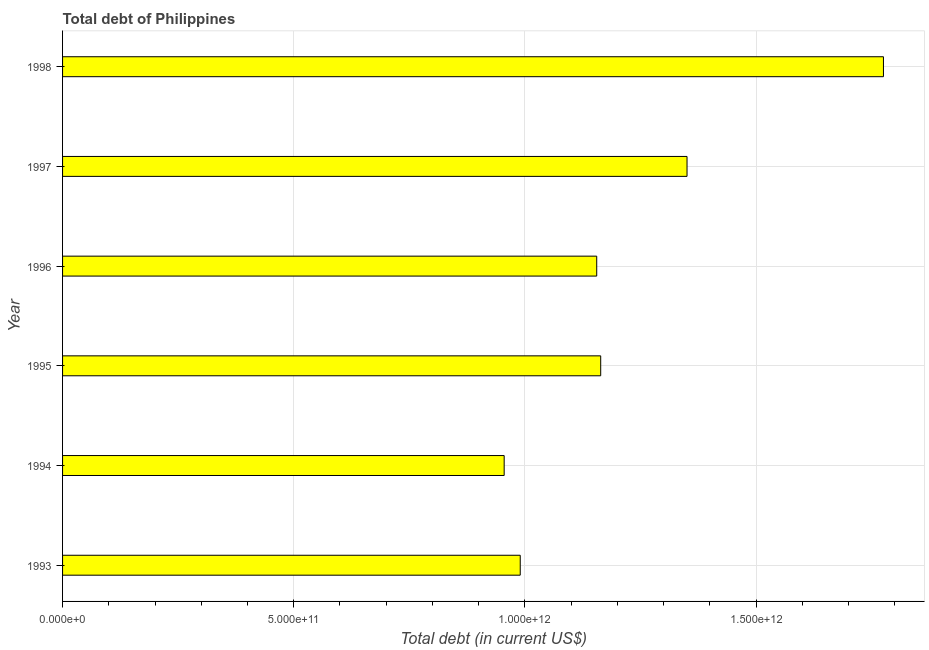Does the graph contain any zero values?
Give a very brief answer. No. What is the title of the graph?
Provide a succinct answer. Total debt of Philippines. What is the label or title of the X-axis?
Make the answer very short. Total debt (in current US$). What is the label or title of the Y-axis?
Give a very brief answer. Year. What is the total debt in 1996?
Provide a succinct answer. 1.16e+12. Across all years, what is the maximum total debt?
Make the answer very short. 1.78e+12. Across all years, what is the minimum total debt?
Offer a terse response. 9.55e+11. In which year was the total debt maximum?
Offer a terse response. 1998. What is the sum of the total debt?
Make the answer very short. 7.39e+12. What is the difference between the total debt in 1994 and 1995?
Provide a short and direct response. -2.09e+11. What is the average total debt per year?
Your answer should be compact. 1.23e+12. What is the median total debt?
Provide a succinct answer. 1.16e+12. What is the ratio of the total debt in 1993 to that in 1997?
Offer a terse response. 0.73. Is the total debt in 1994 less than that in 1998?
Give a very brief answer. Yes. Is the difference between the total debt in 1995 and 1997 greater than the difference between any two years?
Your answer should be compact. No. What is the difference between the highest and the second highest total debt?
Provide a succinct answer. 4.25e+11. What is the difference between the highest and the lowest total debt?
Provide a short and direct response. 8.20e+11. Are all the bars in the graph horizontal?
Your response must be concise. Yes. How many years are there in the graph?
Ensure brevity in your answer.  6. What is the difference between two consecutive major ticks on the X-axis?
Make the answer very short. 5.00e+11. What is the Total debt (in current US$) of 1993?
Give a very brief answer. 9.90e+11. What is the Total debt (in current US$) in 1994?
Your response must be concise. 9.55e+11. What is the Total debt (in current US$) of 1995?
Offer a terse response. 1.16e+12. What is the Total debt (in current US$) of 1996?
Ensure brevity in your answer.  1.16e+12. What is the Total debt (in current US$) in 1997?
Ensure brevity in your answer.  1.35e+12. What is the Total debt (in current US$) of 1998?
Your response must be concise. 1.78e+12. What is the difference between the Total debt (in current US$) in 1993 and 1994?
Make the answer very short. 3.47e+1. What is the difference between the Total debt (in current US$) in 1993 and 1995?
Provide a short and direct response. -1.74e+11. What is the difference between the Total debt (in current US$) in 1993 and 1996?
Your response must be concise. -1.65e+11. What is the difference between the Total debt (in current US$) in 1993 and 1997?
Your answer should be very brief. -3.61e+11. What is the difference between the Total debt (in current US$) in 1993 and 1998?
Your answer should be compact. -7.86e+11. What is the difference between the Total debt (in current US$) in 1994 and 1995?
Ensure brevity in your answer.  -2.09e+11. What is the difference between the Total debt (in current US$) in 1994 and 1996?
Provide a short and direct response. -2.00e+11. What is the difference between the Total debt (in current US$) in 1994 and 1997?
Provide a short and direct response. -3.95e+11. What is the difference between the Total debt (in current US$) in 1994 and 1998?
Offer a very short reply. -8.20e+11. What is the difference between the Total debt (in current US$) in 1995 and 1996?
Provide a short and direct response. 8.61e+09. What is the difference between the Total debt (in current US$) in 1995 and 1997?
Ensure brevity in your answer.  -1.87e+11. What is the difference between the Total debt (in current US$) in 1995 and 1998?
Provide a short and direct response. -6.12e+11. What is the difference between the Total debt (in current US$) in 1996 and 1997?
Your answer should be compact. -1.95e+11. What is the difference between the Total debt (in current US$) in 1996 and 1998?
Your response must be concise. -6.20e+11. What is the difference between the Total debt (in current US$) in 1997 and 1998?
Ensure brevity in your answer.  -4.25e+11. What is the ratio of the Total debt (in current US$) in 1993 to that in 1994?
Offer a terse response. 1.04. What is the ratio of the Total debt (in current US$) in 1993 to that in 1996?
Keep it short and to the point. 0.86. What is the ratio of the Total debt (in current US$) in 1993 to that in 1997?
Provide a succinct answer. 0.73. What is the ratio of the Total debt (in current US$) in 1993 to that in 1998?
Give a very brief answer. 0.56. What is the ratio of the Total debt (in current US$) in 1994 to that in 1995?
Offer a terse response. 0.82. What is the ratio of the Total debt (in current US$) in 1994 to that in 1996?
Give a very brief answer. 0.83. What is the ratio of the Total debt (in current US$) in 1994 to that in 1997?
Make the answer very short. 0.71. What is the ratio of the Total debt (in current US$) in 1994 to that in 1998?
Your answer should be compact. 0.54. What is the ratio of the Total debt (in current US$) in 1995 to that in 1997?
Ensure brevity in your answer.  0.86. What is the ratio of the Total debt (in current US$) in 1995 to that in 1998?
Provide a short and direct response. 0.66. What is the ratio of the Total debt (in current US$) in 1996 to that in 1997?
Make the answer very short. 0.85. What is the ratio of the Total debt (in current US$) in 1996 to that in 1998?
Your answer should be very brief. 0.65. What is the ratio of the Total debt (in current US$) in 1997 to that in 1998?
Your response must be concise. 0.76. 